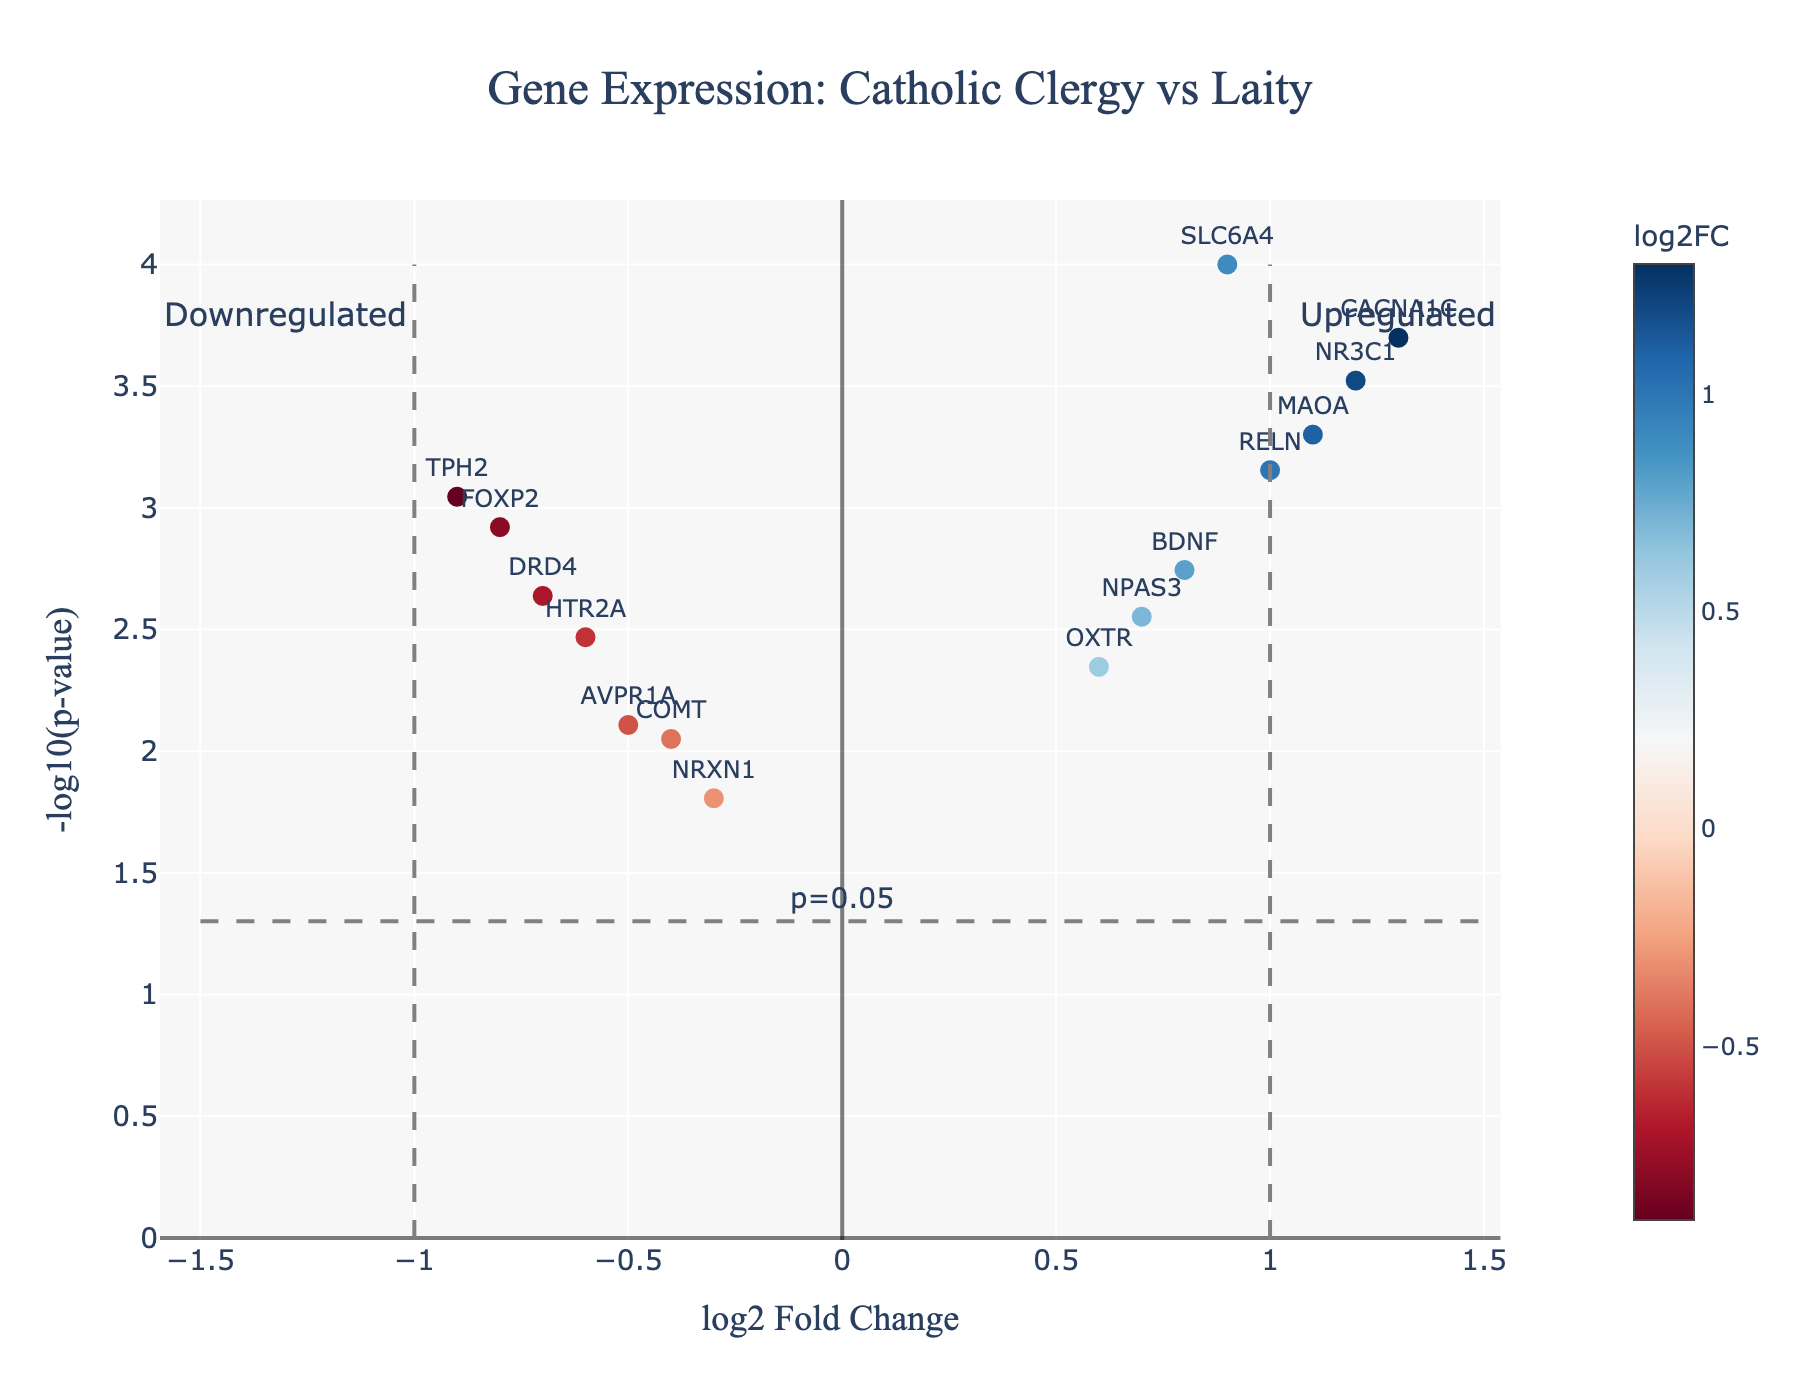What's the title of the figure? The title is visually placed at the top of the figure.
Answer: Gene Expression: Catholic Clergy vs Laity What do the x-axis and y-axis represent? The x-axis shows "log2 Fold Change" and the y-axis shows "-log10(p-value)". These are labeled on the axes of the figure.
Answer: log2 Fold Change and -log10(p-value) How many genes are upregulated? Genes with log2 Fold Change greater than 1 are considered upregulated. The figure marks genes NR3C1, MAOA, RELN, CACNA1C, and SLC6A4 as upregulated. Count the number of points to the right of the vertical line at log2 Fold Change = 1.
Answer: 5 Which gene is the most significantly downregulated? The most significantly downregulated gene will have the highest -log10(p-value) and a negative log2 Fold Change. Identify the point with the lowest x value and the highest y value.
Answer: TPH2 What is the p-value threshold indicated in the figure, and how is it represented? The p-value threshold is 0.05. This is represented by a horizontal line at -log10(p-value) of about 1.3 and labeled with "p=0.05".
Answer: 0.05 Which gene presents the highest log2 Fold Change value? The gene with the highest log2 Fold Change will be the point farthest to the right on the x-axis.
Answer: CACNA1C How is the downregulated gene COMT visually represented in the plot? COMT has a log2 Fold Change of -0.4 and its p-value converts to approximately -log10(0.0089). Find the corresponding point within the negative x-axis and slightly above y = 2.
Answer: A point with log2 Fold Change around -0.4 and y above 2 Which gene has a log2 Fold Change around 0.8 but is less significant in terms of p-value compared to others with similar fold change? For log2 Fold Change around 0.8, compare -log10(p-value) of BDNF vs. other genes around the same fold change. BDNF has a lower p-value significance than CACNA1C.
Answer: BDNF What's the significance level (p-value) of the gene SLC6A4? Check the corresponding point for SLC6A4 and read its p-value from the hover text or calculate -log10(p-value) ~ 4 which indicates p = 0.0001.
Answer: 0.0001 